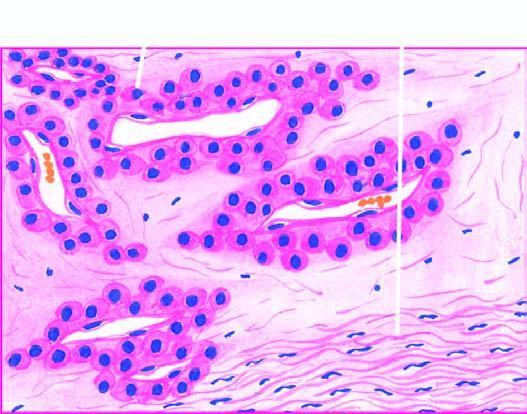re there blood-filled vascular channels lined by endothelial cells and surrounded by nests and masses of glomus cells?
Answer the question using a single word or phrase. Yes 